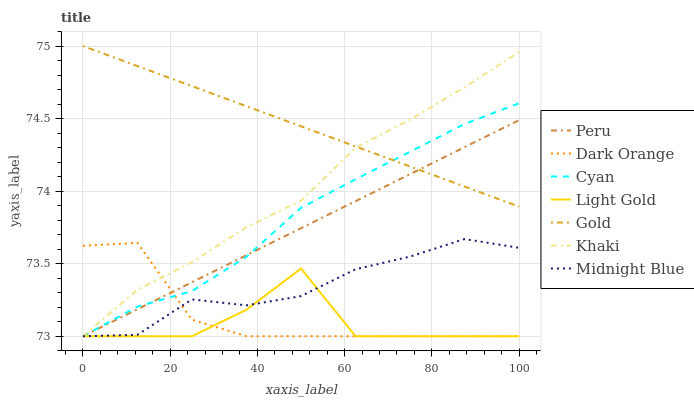Does Light Gold have the minimum area under the curve?
Answer yes or no. Yes. Does Gold have the maximum area under the curve?
Answer yes or no. Yes. Does Khaki have the minimum area under the curve?
Answer yes or no. No. Does Khaki have the maximum area under the curve?
Answer yes or no. No. Is Peru the smoothest?
Answer yes or no. Yes. Is Light Gold the roughest?
Answer yes or no. Yes. Is Khaki the smoothest?
Answer yes or no. No. Is Khaki the roughest?
Answer yes or no. No. Does Dark Orange have the lowest value?
Answer yes or no. Yes. Does Gold have the lowest value?
Answer yes or no. No. Does Gold have the highest value?
Answer yes or no. Yes. Does Khaki have the highest value?
Answer yes or no. No. Is Dark Orange less than Gold?
Answer yes or no. Yes. Is Gold greater than Dark Orange?
Answer yes or no. Yes. Does Light Gold intersect Dark Orange?
Answer yes or no. Yes. Is Light Gold less than Dark Orange?
Answer yes or no. No. Is Light Gold greater than Dark Orange?
Answer yes or no. No. Does Dark Orange intersect Gold?
Answer yes or no. No. 